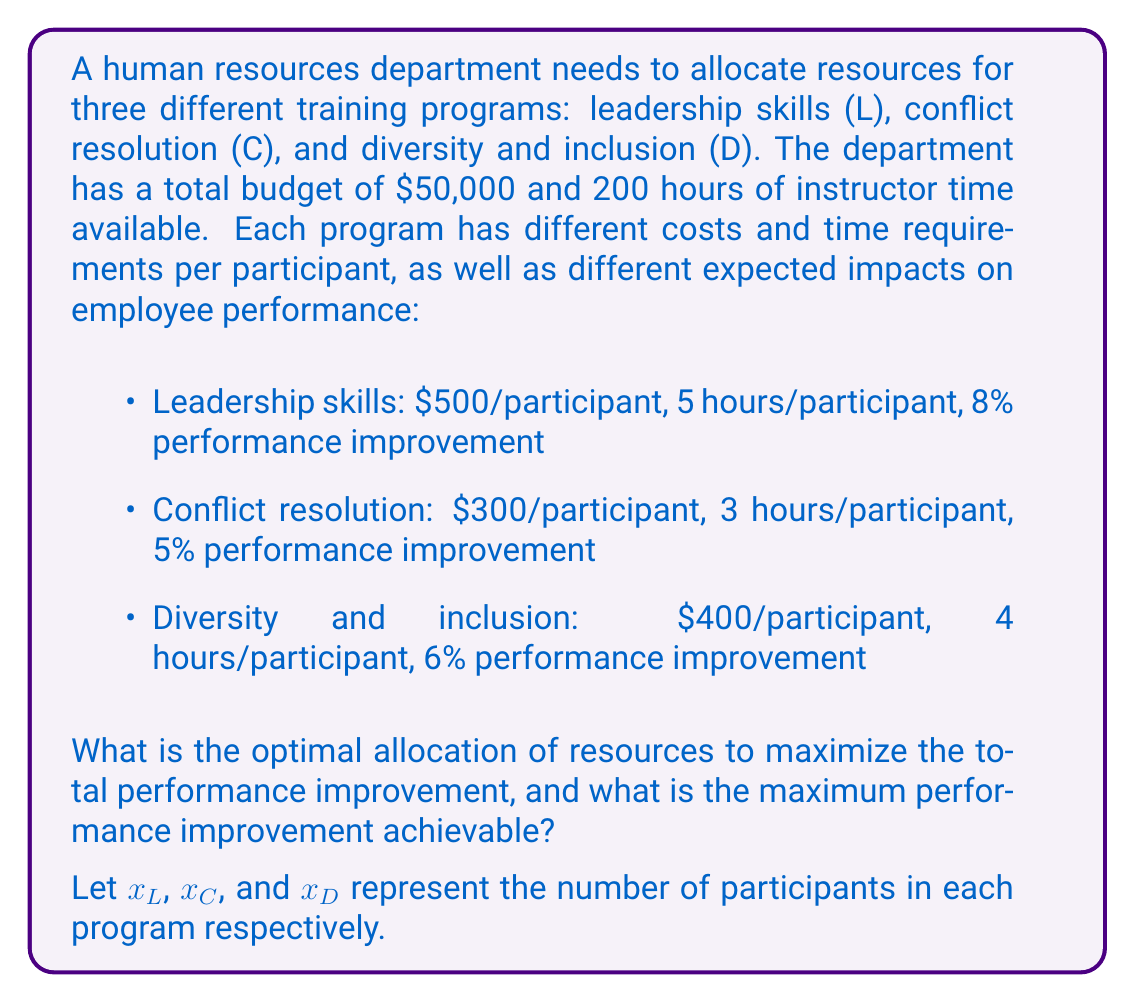Solve this math problem. To solve this problem, we'll use linear programming. We need to:
1. Define the objective function
2. Identify the constraints
3. Set up the linear programming model
4. Solve the model

1. Objective function:
We want to maximize the total performance improvement:
$$\text{Maximize } Z = 8x_L + 5x_C + 6x_D$$

2. Constraints:
a) Budget constraint: 
$$500x_L + 300x_C + 400x_D \leq 50000$$

b) Time constraint:
$$5x_L + 3x_C + 4x_D \leq 200$$

c) Non-negativity constraints:
$$x_L, x_C, x_D \geq 0$$

3. Linear programming model:
$$\text{Maximize } Z = 8x_L + 5x_C + 6x_D$$
Subject to:
$$500x_L + 300x_C + 400x_D \leq 50000$$
$$5x_L + 3x_C + 4x_D \leq 200$$
$$x_L, x_C, x_D \geq 0$$

4. Solving the model:
We can solve this using the simplex method or a linear programming solver. The optimal solution is:

$x_L = 0$
$x_C = 50$
$x_D = 25$

This means:
- 0 participants in the Leadership skills program
- 50 participants in the Conflict resolution program
- 25 participants in the Diversity and inclusion program

The maximum performance improvement achievable is:
$$Z = 8(0) + 5(50) + 6(25) = 250 + 150 = 400$$

We can verify that this solution satisfies the constraints:
Budget: $300(50) + 400(25) = 15000 + 10000 = 25000 \leq 50000$
Time: $3(50) + 4(25) = 150 + 100 = 250 \leq 200$

Both constraints are satisfied, and the solution is optimal.
Answer: The optimal allocation is 0 participants for Leadership skills, 50 participants for Conflict resolution, and 25 participants for Diversity and inclusion. The maximum performance improvement achievable is 400 percentage points. 